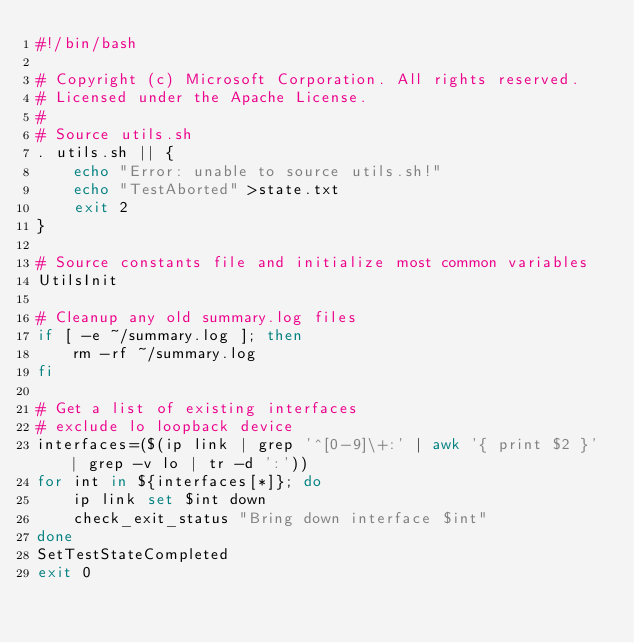Convert code to text. <code><loc_0><loc_0><loc_500><loc_500><_Bash_>#!/bin/bash

# Copyright (c) Microsoft Corporation. All rights reserved.
# Licensed under the Apache License.
#
# Source utils.sh
. utils.sh || {
    echo "Error: unable to source utils.sh!"
    echo "TestAborted" >state.txt
    exit 2
}

# Source constants file and initialize most common variables
UtilsInit

# Cleanup any old summary.log files
if [ -e ~/summary.log ]; then
    rm -rf ~/summary.log
fi

# Get a list of existing interfaces
# exclude lo loopback device
interfaces=($(ip link | grep '^[0-9]\+:' | awk '{ print $2 }' | grep -v lo | tr -d ':'))
for int in ${interfaces[*]}; do
    ip link set $int down
    check_exit_status "Bring down interface $int"
done
SetTestStateCompleted
exit 0
</code> 